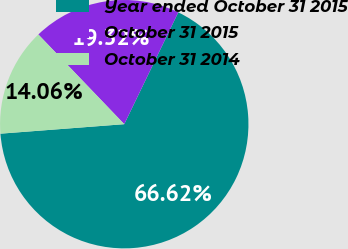<chart> <loc_0><loc_0><loc_500><loc_500><pie_chart><fcel>Year ended October 31 2015<fcel>October 31 2015<fcel>October 31 2014<nl><fcel>66.62%<fcel>19.32%<fcel>14.06%<nl></chart> 